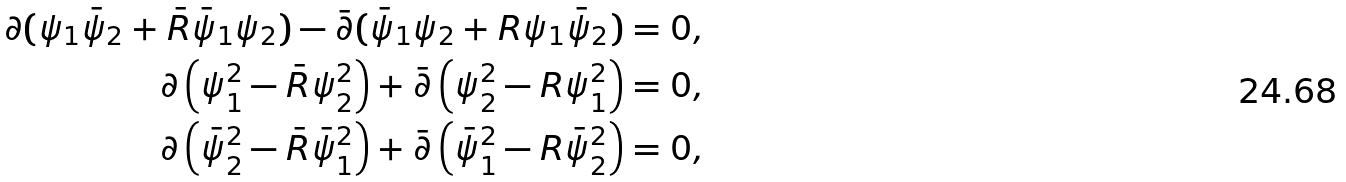Convert formula to latex. <formula><loc_0><loc_0><loc_500><loc_500>\partial ( \psi _ { 1 } \bar { \psi } _ { 2 } + \bar { R } \bar { \psi } _ { 1 } \psi _ { 2 } ) - \bar { \partial } ( \bar { \psi } _ { 1 } \psi _ { 2 } + R \psi _ { 1 } \bar { \psi } _ { 2 } ) = 0 , \\ \partial \left ( \psi ^ { 2 } _ { 1 } - \bar { R } \psi _ { 2 } ^ { 2 } \right ) + \bar { \partial } \left ( \psi _ { 2 } ^ { 2 } - R \psi _ { 1 } ^ { 2 } \right ) = 0 , \\ \partial \left ( \bar { \psi } _ { 2 } ^ { 2 } - \bar { R } \bar { \psi } _ { 1 } ^ { 2 } \right ) + \bar { \partial } \left ( \bar { \psi } _ { 1 } ^ { 2 } - R \bar { \psi } _ { 2 } ^ { 2 } \right ) = 0 ,</formula> 